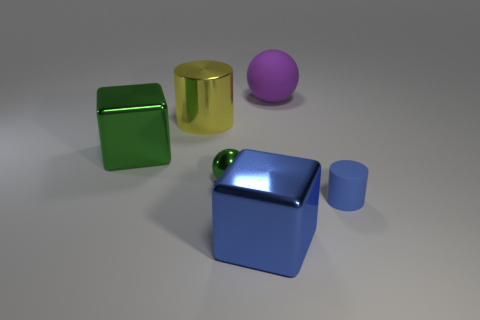Are there any other things that are the same shape as the small matte object? Yes, the small matte object resembles a cylinder, and it shares its shape with the taller golden object beside the blue cube. Both objects have circular bases and are symmetrical around their central axis, characteristic of a cylindrical shape. 